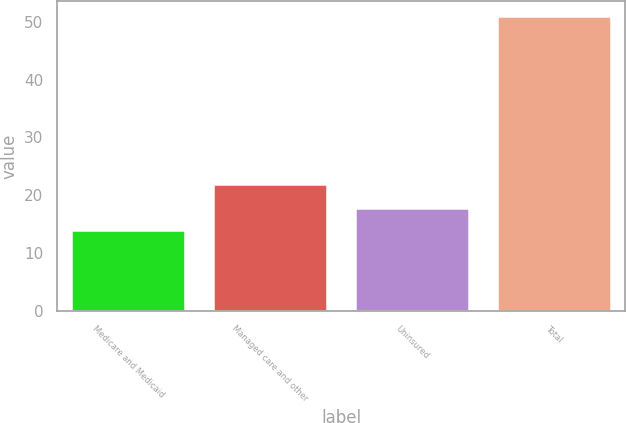<chart> <loc_0><loc_0><loc_500><loc_500><bar_chart><fcel>Medicare and Medicaid<fcel>Managed care and other<fcel>Uninsured<fcel>Total<nl><fcel>14<fcel>22<fcel>17.7<fcel>51<nl></chart> 